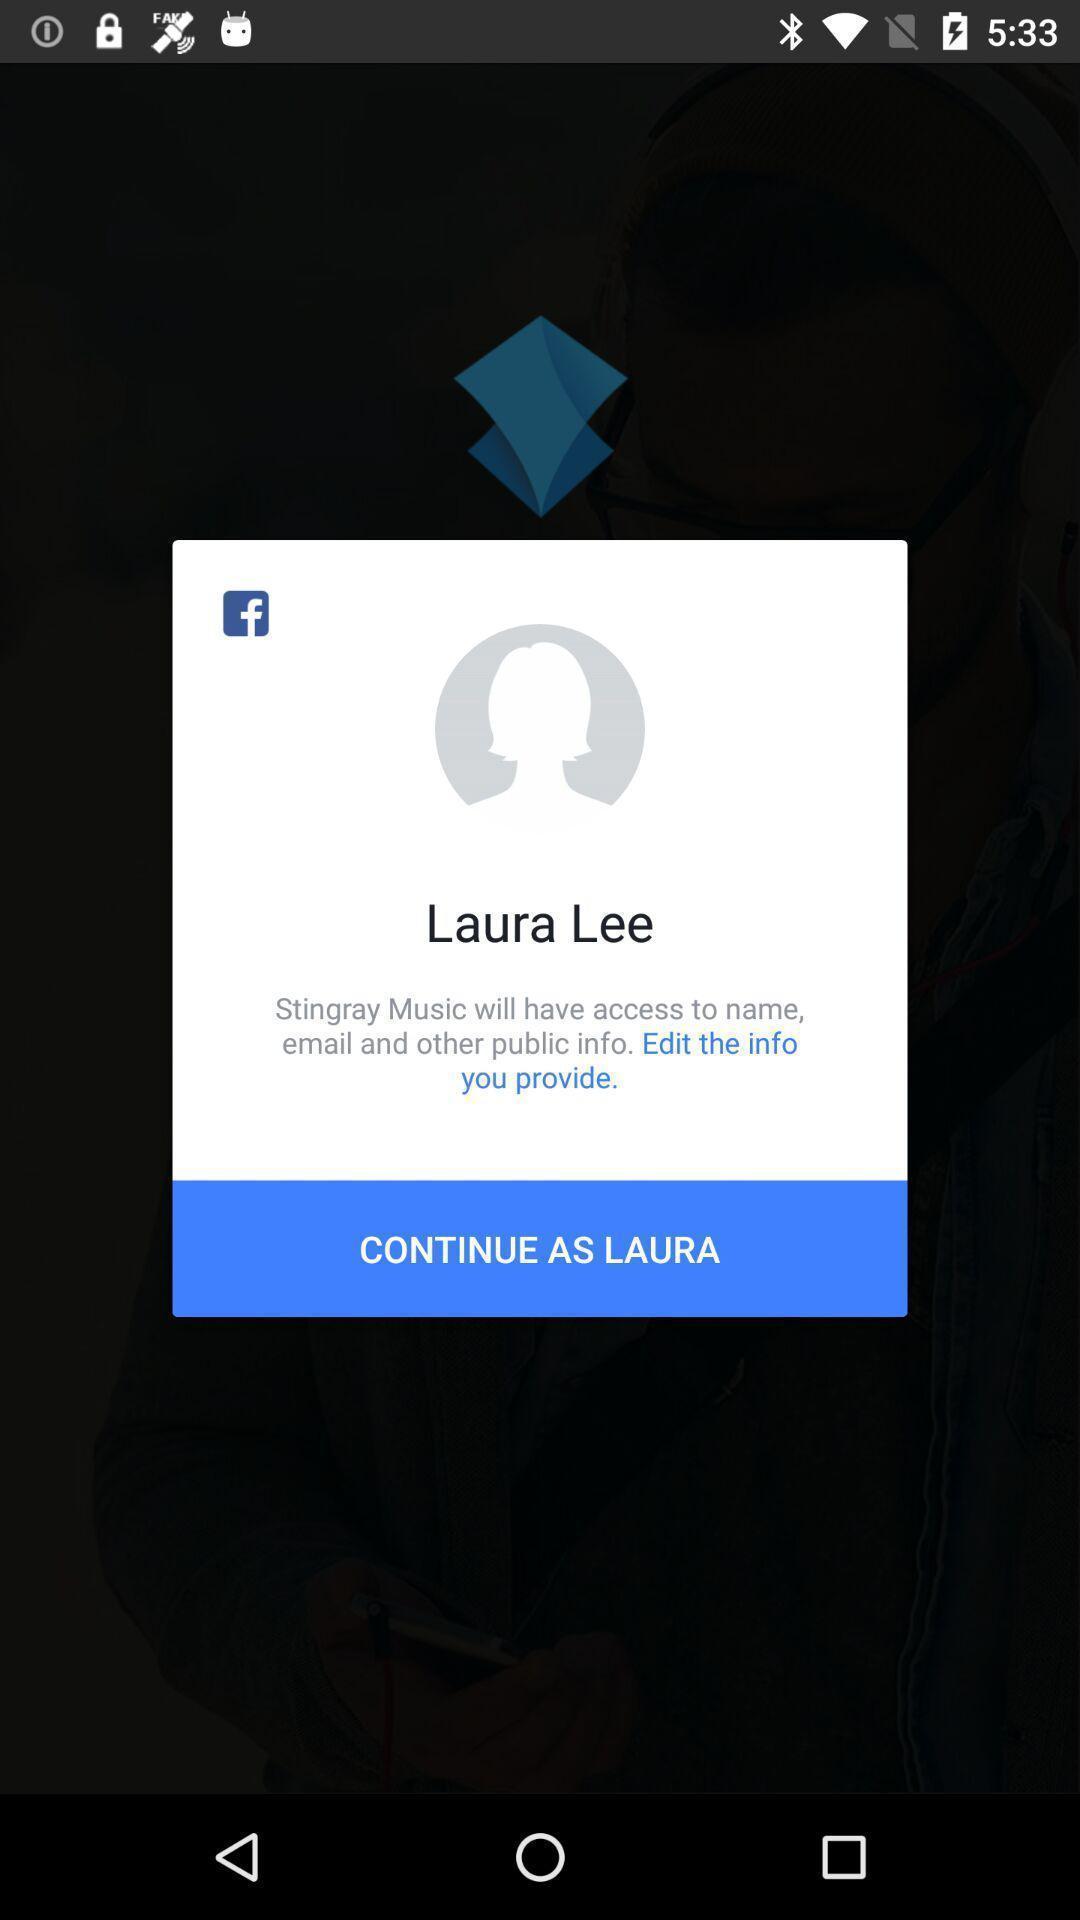Tell me about the visual elements in this screen capture. Pop-up showing legal information with edit option. 